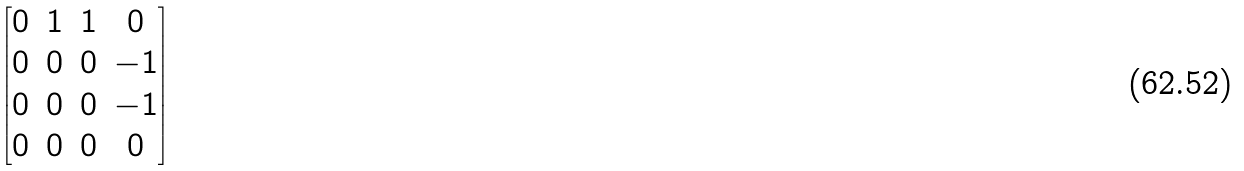<formula> <loc_0><loc_0><loc_500><loc_500>\begin{bmatrix} 0 & 1 & 1 & 0 \\ 0 & 0 & 0 & - 1 \\ 0 & 0 & 0 & - 1 \\ 0 & 0 & 0 & 0 \end{bmatrix}</formula> 